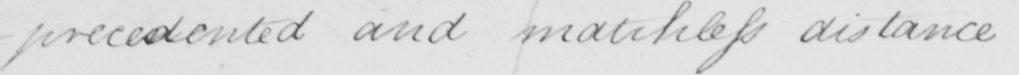What is written in this line of handwriting? -precedented and matchless distance 